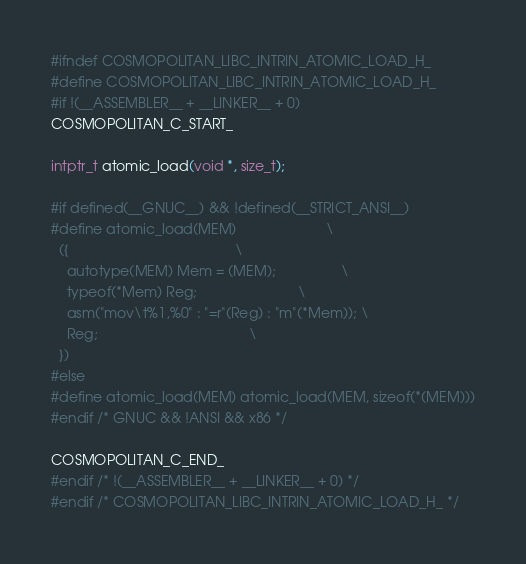Convert code to text. <code><loc_0><loc_0><loc_500><loc_500><_C_>#ifndef COSMOPOLITAN_LIBC_INTRIN_ATOMIC_LOAD_H_
#define COSMOPOLITAN_LIBC_INTRIN_ATOMIC_LOAD_H_
#if !(__ASSEMBLER__ + __LINKER__ + 0)
COSMOPOLITAN_C_START_

intptr_t atomic_load(void *, size_t);

#if defined(__GNUC__) && !defined(__STRICT_ANSI__)
#define atomic_load(MEM)                       \
  ({                                           \
    autotype(MEM) Mem = (MEM);                 \
    typeof(*Mem) Reg;                          \
    asm("mov\t%1,%0" : "=r"(Reg) : "m"(*Mem)); \
    Reg;                                       \
  })
#else
#define atomic_load(MEM) atomic_load(MEM, sizeof(*(MEM)))
#endif /* GNUC && !ANSI && x86 */

COSMOPOLITAN_C_END_
#endif /* !(__ASSEMBLER__ + __LINKER__ + 0) */
#endif /* COSMOPOLITAN_LIBC_INTRIN_ATOMIC_LOAD_H_ */
</code> 